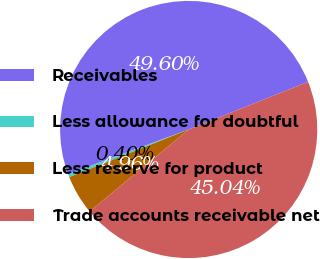Convert chart. <chart><loc_0><loc_0><loc_500><loc_500><pie_chart><fcel>Receivables<fcel>Less allowance for doubtful<fcel>Less reserve for product<fcel>Trade accounts receivable net<nl><fcel>49.6%<fcel>0.4%<fcel>4.96%<fcel>45.04%<nl></chart> 